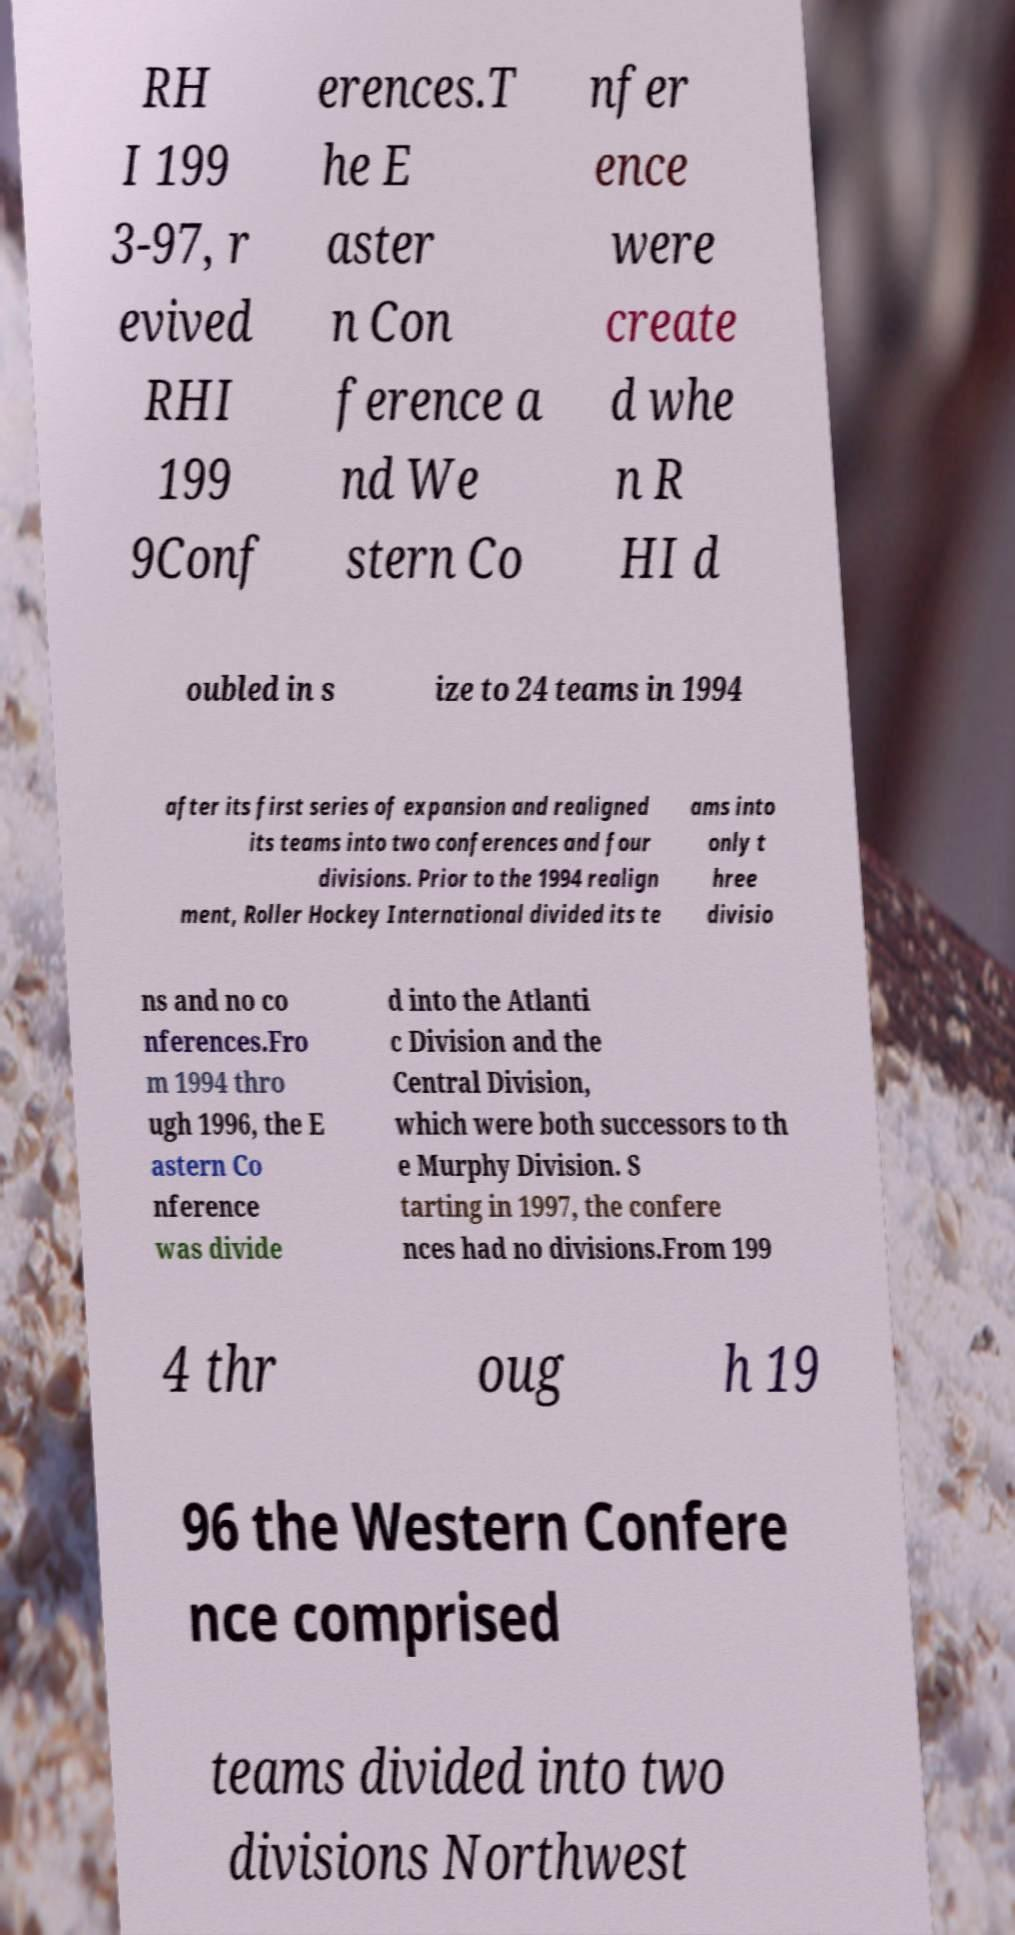Please read and relay the text visible in this image. What does it say? RH I 199 3-97, r evived RHI 199 9Conf erences.T he E aster n Con ference a nd We stern Co nfer ence were create d whe n R HI d oubled in s ize to 24 teams in 1994 after its first series of expansion and realigned its teams into two conferences and four divisions. Prior to the 1994 realign ment, Roller Hockey International divided its te ams into only t hree divisio ns and no co nferences.Fro m 1994 thro ugh 1996, the E astern Co nference was divide d into the Atlanti c Division and the Central Division, which were both successors to th e Murphy Division. S tarting in 1997, the confere nces had no divisions.From 199 4 thr oug h 19 96 the Western Confere nce comprised teams divided into two divisions Northwest 